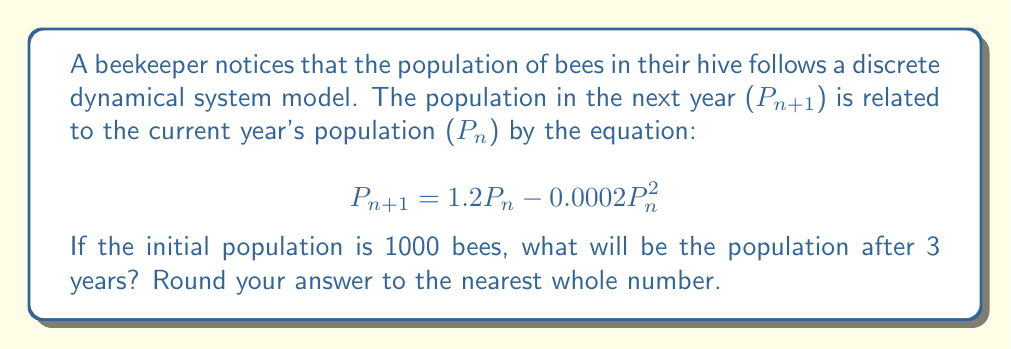Teach me how to tackle this problem. To solve this problem, we need to iterate the given discrete dynamical system equation for three years, starting with the initial population of 1000 bees.

Let's calculate step by step:

1. Initial population: $P_0 = 1000$

2. After 1 year ($n = 1$):
   $$\begin{align}
   P_1 &= 1.2P_0 - 0.0002P_0^2 \\
   &= 1.2(1000) - 0.0002(1000)^2 \\
   &= 1200 - 200 \\
   &= 1000
   \end{align}$$

3. After 2 years ($n = 2$):
   $$\begin{align}
   P_2 &= 1.2P_1 - 0.0002P_1^2 \\
   &= 1.2(1000) - 0.0002(1000)^2 \\
   &= 1200 - 200 \\
   &= 1000
   \end{align}$$

4. After 3 years ($n = 3$):
   $$\begin{align}
   P_3 &= 1.2P_2 - 0.0002P_2^2 \\
   &= 1.2(1000) - 0.0002(1000)^2 \\
   &= 1200 - 200 \\
   &= 1000
   \end{align}$$

We can see that the population remains stable at 1000 bees for all three years. This is because 1000 is a fixed point of the given discrete dynamical system. When $P_n = 1000$, $P_{n+1}$ will also equal 1000.

To verify this mathematically:

$$\begin{align}
1000 &= 1.2(1000) - 0.0002(1000)^2 \\
1000 &= 1200 - 200 \\
1000 &= 1000
\end{align}$$

This equality holds true, confirming that 1000 is indeed a fixed point of the system.
Answer: 1000 bees 